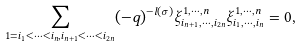Convert formula to latex. <formula><loc_0><loc_0><loc_500><loc_500>\sum _ { 1 = i _ { 1 } < \cdots < i _ { n } , i _ { n + 1 } < \cdots < i _ { 2 n } } ( - q ) ^ { - l ( \sigma ) } \xi ^ { 1 , \cdots , n } _ { i _ { n + 1 } , \cdots , i _ { 2 n } } \xi ^ { 1 , \cdots , n } _ { i _ { 1 } , \cdots , i _ { n } } = 0 ,</formula> 